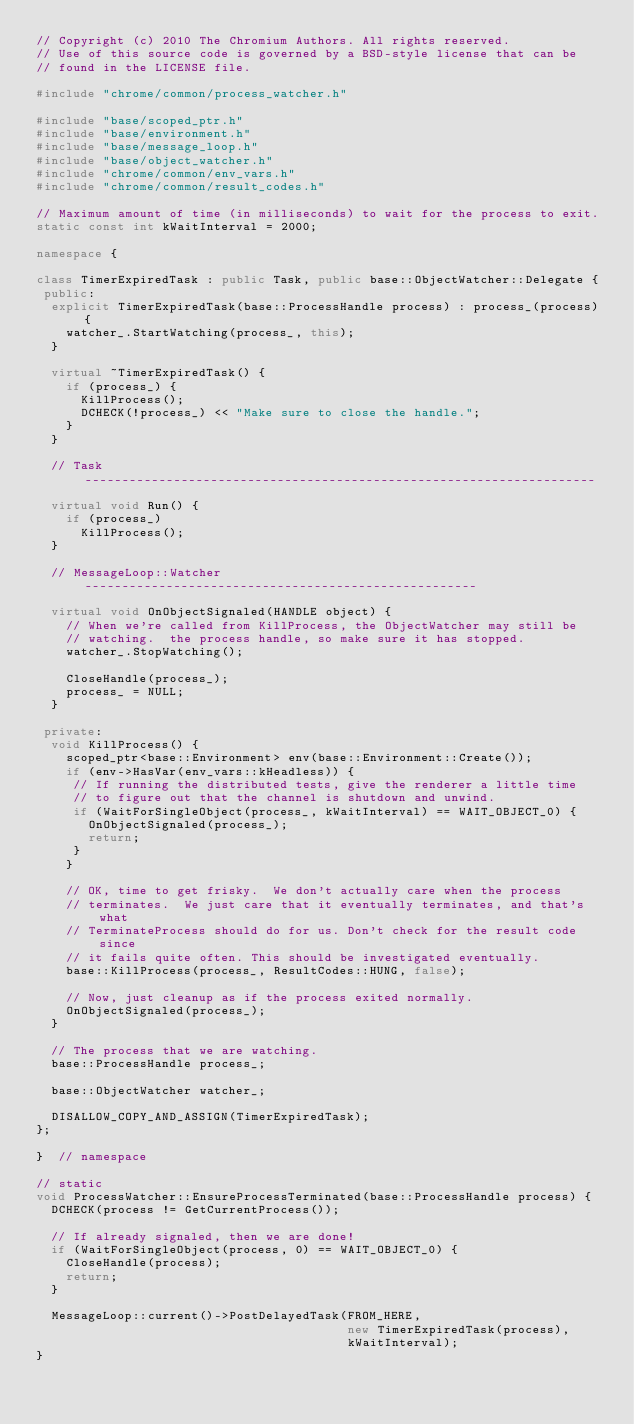Convert code to text. <code><loc_0><loc_0><loc_500><loc_500><_C++_>// Copyright (c) 2010 The Chromium Authors. All rights reserved.
// Use of this source code is governed by a BSD-style license that can be
// found in the LICENSE file.

#include "chrome/common/process_watcher.h"

#include "base/scoped_ptr.h"
#include "base/environment.h"
#include "base/message_loop.h"
#include "base/object_watcher.h"
#include "chrome/common/env_vars.h"
#include "chrome/common/result_codes.h"

// Maximum amount of time (in milliseconds) to wait for the process to exit.
static const int kWaitInterval = 2000;

namespace {

class TimerExpiredTask : public Task, public base::ObjectWatcher::Delegate {
 public:
  explicit TimerExpiredTask(base::ProcessHandle process) : process_(process) {
    watcher_.StartWatching(process_, this);
  }

  virtual ~TimerExpiredTask() {
    if (process_) {
      KillProcess();
      DCHECK(!process_) << "Make sure to close the handle.";
    }
  }

  // Task ---------------------------------------------------------------------

  virtual void Run() {
    if (process_)
      KillProcess();
  }

  // MessageLoop::Watcher -----------------------------------------------------

  virtual void OnObjectSignaled(HANDLE object) {
    // When we're called from KillProcess, the ObjectWatcher may still be
    // watching.  the process handle, so make sure it has stopped.
    watcher_.StopWatching();

    CloseHandle(process_);
    process_ = NULL;
  }

 private:
  void KillProcess() {
    scoped_ptr<base::Environment> env(base::Environment::Create());
    if (env->HasVar(env_vars::kHeadless)) {
     // If running the distributed tests, give the renderer a little time
     // to figure out that the channel is shutdown and unwind.
     if (WaitForSingleObject(process_, kWaitInterval) == WAIT_OBJECT_0) {
       OnObjectSignaled(process_);
       return;
     }
    }

    // OK, time to get frisky.  We don't actually care when the process
    // terminates.  We just care that it eventually terminates, and that's what
    // TerminateProcess should do for us. Don't check for the result code since
    // it fails quite often. This should be investigated eventually.
    base::KillProcess(process_, ResultCodes::HUNG, false);

    // Now, just cleanup as if the process exited normally.
    OnObjectSignaled(process_);
  }

  // The process that we are watching.
  base::ProcessHandle process_;

  base::ObjectWatcher watcher_;

  DISALLOW_COPY_AND_ASSIGN(TimerExpiredTask);
};

}  // namespace

// static
void ProcessWatcher::EnsureProcessTerminated(base::ProcessHandle process) {
  DCHECK(process != GetCurrentProcess());

  // If already signaled, then we are done!
  if (WaitForSingleObject(process, 0) == WAIT_OBJECT_0) {
    CloseHandle(process);
    return;
  }

  MessageLoop::current()->PostDelayedTask(FROM_HERE,
                                          new TimerExpiredTask(process),
                                          kWaitInterval);
}
</code> 